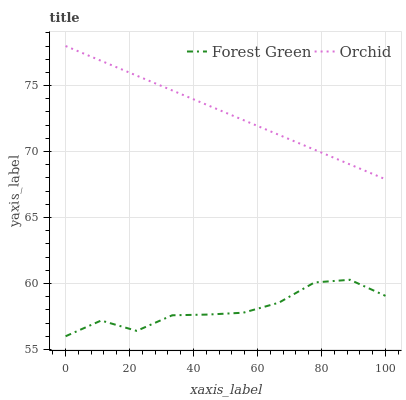Does Forest Green have the minimum area under the curve?
Answer yes or no. Yes. Does Orchid have the maximum area under the curve?
Answer yes or no. Yes. Does Orchid have the minimum area under the curve?
Answer yes or no. No. Is Orchid the smoothest?
Answer yes or no. Yes. Is Forest Green the roughest?
Answer yes or no. Yes. Is Orchid the roughest?
Answer yes or no. No. Does Orchid have the lowest value?
Answer yes or no. No. Does Orchid have the highest value?
Answer yes or no. Yes. Is Forest Green less than Orchid?
Answer yes or no. Yes. Is Orchid greater than Forest Green?
Answer yes or no. Yes. Does Forest Green intersect Orchid?
Answer yes or no. No. 